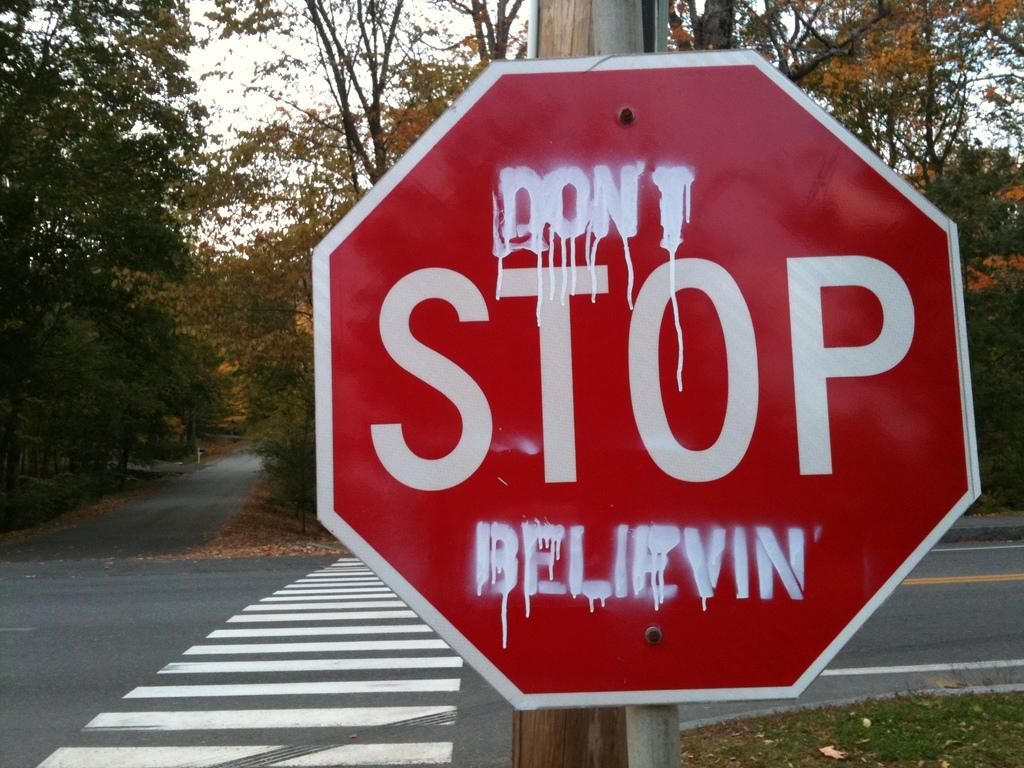<image>
Describe the image concisely. A sign with "Don't Stop Believing" written on it. 